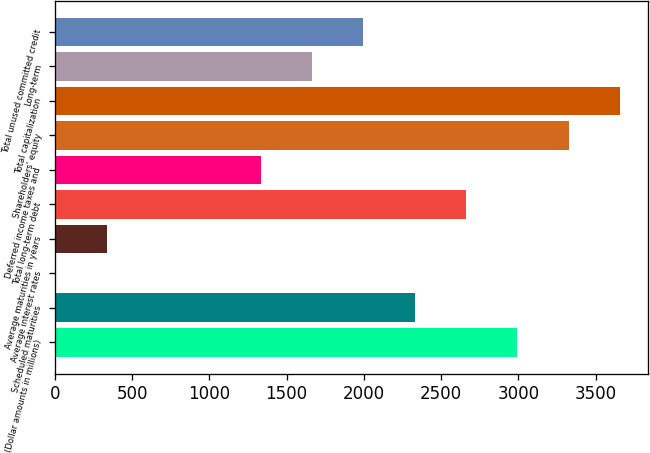<chart> <loc_0><loc_0><loc_500><loc_500><bar_chart><fcel>(Dollar amounts in millions)<fcel>Scheduled maturities<fcel>Average interest rates<fcel>Average maturities in years<fcel>Total long-term debt<fcel>Deferred income taxes and<fcel>Shareholders' equity<fcel>Total capitalization<fcel>Long-term<fcel>Total unused committed credit<nl><fcel>2994.8<fcel>2330.4<fcel>5<fcel>337.2<fcel>2662.6<fcel>1333.8<fcel>3327<fcel>3659.2<fcel>1666<fcel>1998.2<nl></chart> 